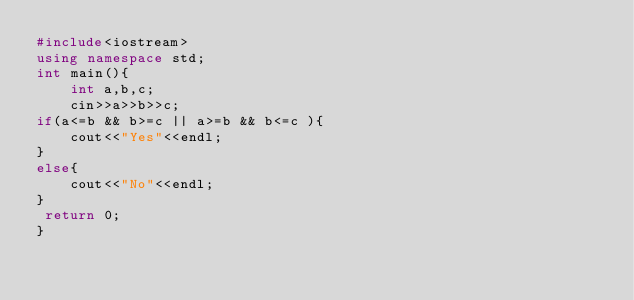<code> <loc_0><loc_0><loc_500><loc_500><_C++_>#include<iostream>
using namespace std;
int main(){
    int a,b,c;
    cin>>a>>b>>c;
if(a<=b && b>=c || a>=b && b<=c ){
    cout<<"Yes"<<endl;
}
else{
    cout<<"No"<<endl;
}
 return 0;
}
</code> 